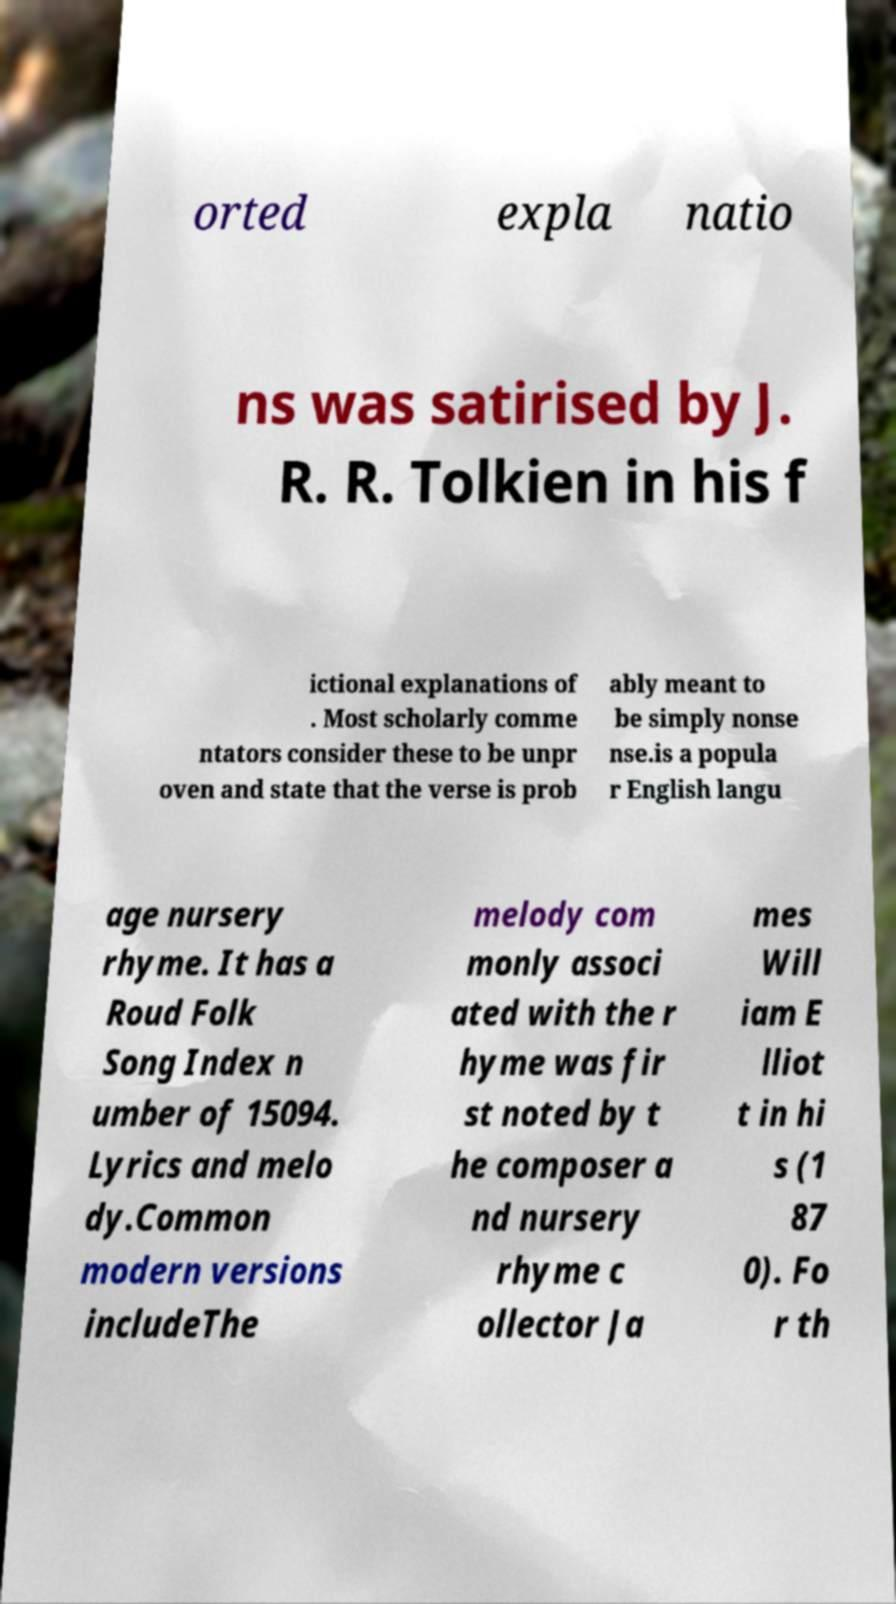I need the written content from this picture converted into text. Can you do that? orted expla natio ns was satirised by J. R. R. Tolkien in his f ictional explanations of . Most scholarly comme ntators consider these to be unpr oven and state that the verse is prob ably meant to be simply nonse nse.is a popula r English langu age nursery rhyme. It has a Roud Folk Song Index n umber of 15094. Lyrics and melo dy.Common modern versions includeThe melody com monly associ ated with the r hyme was fir st noted by t he composer a nd nursery rhyme c ollector Ja mes Will iam E lliot t in hi s (1 87 0). Fo r th 